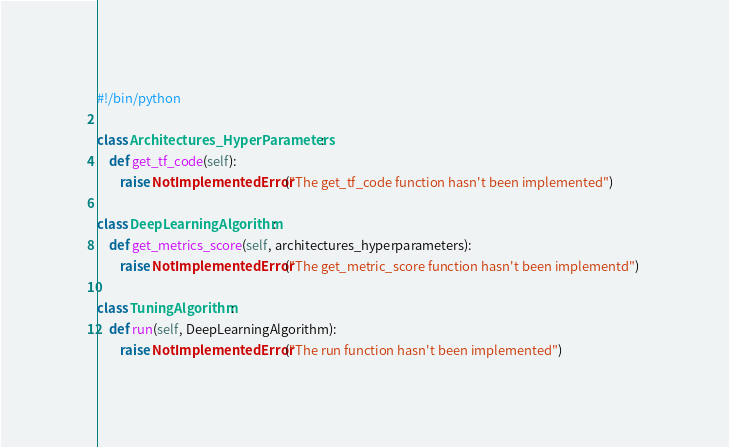Convert code to text. <code><loc_0><loc_0><loc_500><loc_500><_Python_>#!/bin/python

class Architectures_HyperParameters:
    def get_tf_code(self):
        raise NotImplementedError("The get_tf_code function hasn't been implemented")

class DeepLearningAlgorithm:
    def get_metrics_score(self, architectures_hyperparameters):
        raise NotImplementedError("The get_metric_score function hasn't been implementd") 

class TuningAlgorithm:
    def run(self, DeepLearningAlgorithm):
        raise NotImplementedError("The run function hasn't been implemented")
</code> 